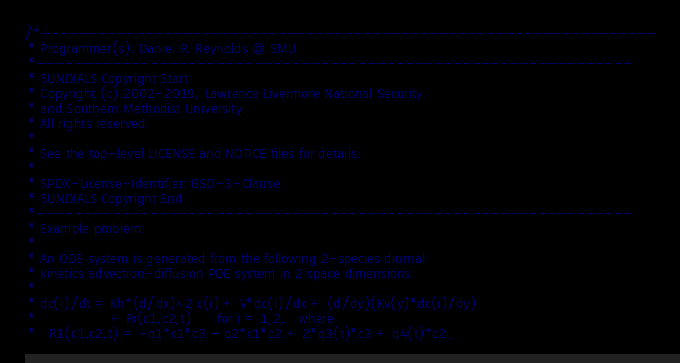Convert code to text. <code><loc_0><loc_0><loc_500><loc_500><_C_>/*-----------------------------------------------------------------
 * Programmer(s): Daniel R. Reynolds @ SMU
 *---------------------------------------------------------------
 * SUNDIALS Copyright Start
 * Copyright (c) 2002-2019, Lawrence Livermore National Security
 * and Southern Methodist University.
 * All rights reserved.
 *
 * See the top-level LICENSE and NOTICE files for details.
 *
 * SPDX-License-Identifier: BSD-3-Clause
 * SUNDIALS Copyright End
 *---------------------------------------------------------------
 * Example problem:
 *
 * An ODE system is generated from the following 2-species diurnal
 * kinetics advection-diffusion PDE system in 2 space dimensions:
 *
 * dc(i)/dt = Kh*(d/dx)^2 c(i) + V*dc(i)/dx + (d/dy)(Kv(y)*dc(i)/dy)
 *                 + Ri(c1,c2,t)      for i = 1,2,   where
 *   R1(c1,c2,t) = -q1*c1*c3 - q2*c1*c2 + 2*q3(t)*c3 + q4(t)*c2 ,</code> 